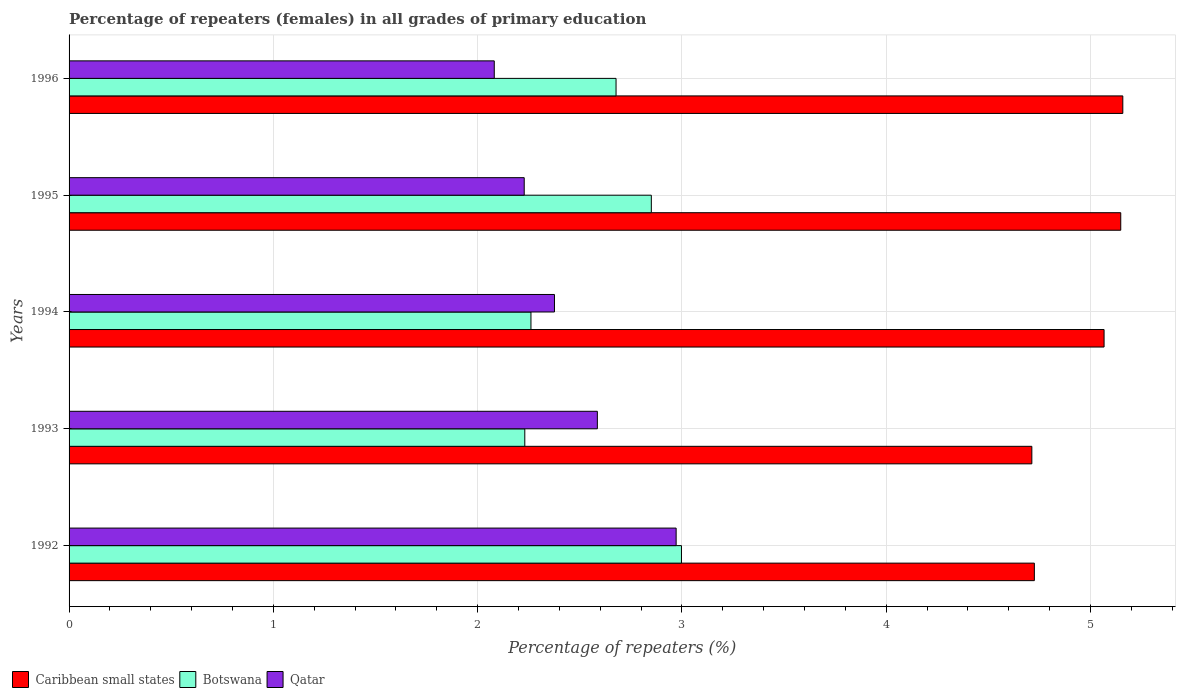How many different coloured bars are there?
Provide a succinct answer. 3. How many groups of bars are there?
Offer a very short reply. 5. How many bars are there on the 3rd tick from the top?
Make the answer very short. 3. How many bars are there on the 2nd tick from the bottom?
Ensure brevity in your answer.  3. What is the percentage of repeaters (females) in Qatar in 1996?
Make the answer very short. 2.08. Across all years, what is the maximum percentage of repeaters (females) in Botswana?
Make the answer very short. 3. Across all years, what is the minimum percentage of repeaters (females) in Caribbean small states?
Make the answer very short. 4.71. In which year was the percentage of repeaters (females) in Botswana minimum?
Ensure brevity in your answer.  1993. What is the total percentage of repeaters (females) in Qatar in the graph?
Make the answer very short. 12.24. What is the difference between the percentage of repeaters (females) in Caribbean small states in 1992 and that in 1995?
Keep it short and to the point. -0.42. What is the difference between the percentage of repeaters (females) in Qatar in 1992 and the percentage of repeaters (females) in Botswana in 1996?
Make the answer very short. 0.29. What is the average percentage of repeaters (females) in Qatar per year?
Provide a short and direct response. 2.45. In the year 1995, what is the difference between the percentage of repeaters (females) in Qatar and percentage of repeaters (females) in Caribbean small states?
Offer a very short reply. -2.92. In how many years, is the percentage of repeaters (females) in Qatar greater than 0.4 %?
Ensure brevity in your answer.  5. What is the ratio of the percentage of repeaters (females) in Caribbean small states in 1994 to that in 1996?
Make the answer very short. 0.98. Is the percentage of repeaters (females) in Qatar in 1992 less than that in 1994?
Offer a very short reply. No. What is the difference between the highest and the second highest percentage of repeaters (females) in Caribbean small states?
Offer a terse response. 0.01. What is the difference between the highest and the lowest percentage of repeaters (females) in Caribbean small states?
Give a very brief answer. 0.45. In how many years, is the percentage of repeaters (females) in Qatar greater than the average percentage of repeaters (females) in Qatar taken over all years?
Your response must be concise. 2. What does the 3rd bar from the top in 1995 represents?
Provide a short and direct response. Caribbean small states. What does the 3rd bar from the bottom in 1992 represents?
Your answer should be compact. Qatar. How many bars are there?
Keep it short and to the point. 15. Are all the bars in the graph horizontal?
Provide a short and direct response. Yes. Does the graph contain any zero values?
Ensure brevity in your answer.  No. Does the graph contain grids?
Keep it short and to the point. Yes. How many legend labels are there?
Give a very brief answer. 3. What is the title of the graph?
Provide a short and direct response. Percentage of repeaters (females) in all grades of primary education. What is the label or title of the X-axis?
Your answer should be very brief. Percentage of repeaters (%). What is the label or title of the Y-axis?
Offer a terse response. Years. What is the Percentage of repeaters (%) in Caribbean small states in 1992?
Your answer should be compact. 4.73. What is the Percentage of repeaters (%) in Botswana in 1992?
Give a very brief answer. 3. What is the Percentage of repeaters (%) of Qatar in 1992?
Give a very brief answer. 2.97. What is the Percentage of repeaters (%) in Caribbean small states in 1993?
Your response must be concise. 4.71. What is the Percentage of repeaters (%) in Botswana in 1993?
Your answer should be compact. 2.23. What is the Percentage of repeaters (%) in Qatar in 1993?
Make the answer very short. 2.59. What is the Percentage of repeaters (%) of Caribbean small states in 1994?
Offer a terse response. 5.07. What is the Percentage of repeaters (%) of Botswana in 1994?
Keep it short and to the point. 2.26. What is the Percentage of repeaters (%) in Qatar in 1994?
Ensure brevity in your answer.  2.38. What is the Percentage of repeaters (%) of Caribbean small states in 1995?
Your answer should be very brief. 5.15. What is the Percentage of repeaters (%) in Botswana in 1995?
Give a very brief answer. 2.85. What is the Percentage of repeaters (%) in Qatar in 1995?
Your answer should be compact. 2.23. What is the Percentage of repeaters (%) in Caribbean small states in 1996?
Keep it short and to the point. 5.16. What is the Percentage of repeaters (%) of Botswana in 1996?
Offer a terse response. 2.68. What is the Percentage of repeaters (%) of Qatar in 1996?
Make the answer very short. 2.08. Across all years, what is the maximum Percentage of repeaters (%) of Caribbean small states?
Offer a terse response. 5.16. Across all years, what is the maximum Percentage of repeaters (%) of Botswana?
Ensure brevity in your answer.  3. Across all years, what is the maximum Percentage of repeaters (%) in Qatar?
Ensure brevity in your answer.  2.97. Across all years, what is the minimum Percentage of repeaters (%) of Caribbean small states?
Make the answer very short. 4.71. Across all years, what is the minimum Percentage of repeaters (%) of Botswana?
Keep it short and to the point. 2.23. Across all years, what is the minimum Percentage of repeaters (%) of Qatar?
Make the answer very short. 2.08. What is the total Percentage of repeaters (%) in Caribbean small states in the graph?
Your response must be concise. 24.81. What is the total Percentage of repeaters (%) of Botswana in the graph?
Ensure brevity in your answer.  13.02. What is the total Percentage of repeaters (%) of Qatar in the graph?
Make the answer very short. 12.24. What is the difference between the Percentage of repeaters (%) in Caribbean small states in 1992 and that in 1993?
Offer a very short reply. 0.01. What is the difference between the Percentage of repeaters (%) in Botswana in 1992 and that in 1993?
Provide a succinct answer. 0.77. What is the difference between the Percentage of repeaters (%) of Qatar in 1992 and that in 1993?
Your answer should be compact. 0.39. What is the difference between the Percentage of repeaters (%) in Caribbean small states in 1992 and that in 1994?
Your answer should be compact. -0.34. What is the difference between the Percentage of repeaters (%) in Botswana in 1992 and that in 1994?
Your response must be concise. 0.74. What is the difference between the Percentage of repeaters (%) in Qatar in 1992 and that in 1994?
Your answer should be very brief. 0.6. What is the difference between the Percentage of repeaters (%) of Caribbean small states in 1992 and that in 1995?
Your response must be concise. -0.42. What is the difference between the Percentage of repeaters (%) in Botswana in 1992 and that in 1995?
Ensure brevity in your answer.  0.15. What is the difference between the Percentage of repeaters (%) of Qatar in 1992 and that in 1995?
Make the answer very short. 0.74. What is the difference between the Percentage of repeaters (%) of Caribbean small states in 1992 and that in 1996?
Offer a very short reply. -0.43. What is the difference between the Percentage of repeaters (%) of Botswana in 1992 and that in 1996?
Your answer should be compact. 0.32. What is the difference between the Percentage of repeaters (%) in Qatar in 1992 and that in 1996?
Make the answer very short. 0.89. What is the difference between the Percentage of repeaters (%) of Caribbean small states in 1993 and that in 1994?
Ensure brevity in your answer.  -0.35. What is the difference between the Percentage of repeaters (%) of Botswana in 1993 and that in 1994?
Provide a succinct answer. -0.03. What is the difference between the Percentage of repeaters (%) of Qatar in 1993 and that in 1994?
Make the answer very short. 0.21. What is the difference between the Percentage of repeaters (%) of Caribbean small states in 1993 and that in 1995?
Give a very brief answer. -0.44. What is the difference between the Percentage of repeaters (%) in Botswana in 1993 and that in 1995?
Ensure brevity in your answer.  -0.62. What is the difference between the Percentage of repeaters (%) in Qatar in 1993 and that in 1995?
Give a very brief answer. 0.36. What is the difference between the Percentage of repeaters (%) in Caribbean small states in 1993 and that in 1996?
Give a very brief answer. -0.45. What is the difference between the Percentage of repeaters (%) of Botswana in 1993 and that in 1996?
Offer a very short reply. -0.45. What is the difference between the Percentage of repeaters (%) of Qatar in 1993 and that in 1996?
Keep it short and to the point. 0.5. What is the difference between the Percentage of repeaters (%) of Caribbean small states in 1994 and that in 1995?
Offer a terse response. -0.08. What is the difference between the Percentage of repeaters (%) in Botswana in 1994 and that in 1995?
Offer a terse response. -0.59. What is the difference between the Percentage of repeaters (%) of Qatar in 1994 and that in 1995?
Offer a terse response. 0.15. What is the difference between the Percentage of repeaters (%) of Caribbean small states in 1994 and that in 1996?
Give a very brief answer. -0.09. What is the difference between the Percentage of repeaters (%) in Botswana in 1994 and that in 1996?
Your answer should be compact. -0.42. What is the difference between the Percentage of repeaters (%) in Qatar in 1994 and that in 1996?
Keep it short and to the point. 0.29. What is the difference between the Percentage of repeaters (%) in Caribbean small states in 1995 and that in 1996?
Offer a terse response. -0.01. What is the difference between the Percentage of repeaters (%) in Botswana in 1995 and that in 1996?
Offer a terse response. 0.17. What is the difference between the Percentage of repeaters (%) in Qatar in 1995 and that in 1996?
Your response must be concise. 0.15. What is the difference between the Percentage of repeaters (%) in Caribbean small states in 1992 and the Percentage of repeaters (%) in Botswana in 1993?
Offer a terse response. 2.49. What is the difference between the Percentage of repeaters (%) of Caribbean small states in 1992 and the Percentage of repeaters (%) of Qatar in 1993?
Give a very brief answer. 2.14. What is the difference between the Percentage of repeaters (%) in Botswana in 1992 and the Percentage of repeaters (%) in Qatar in 1993?
Keep it short and to the point. 0.41. What is the difference between the Percentage of repeaters (%) of Caribbean small states in 1992 and the Percentage of repeaters (%) of Botswana in 1994?
Offer a very short reply. 2.46. What is the difference between the Percentage of repeaters (%) of Caribbean small states in 1992 and the Percentage of repeaters (%) of Qatar in 1994?
Make the answer very short. 2.35. What is the difference between the Percentage of repeaters (%) of Botswana in 1992 and the Percentage of repeaters (%) of Qatar in 1994?
Your answer should be very brief. 0.62. What is the difference between the Percentage of repeaters (%) of Caribbean small states in 1992 and the Percentage of repeaters (%) of Botswana in 1995?
Your response must be concise. 1.88. What is the difference between the Percentage of repeaters (%) in Caribbean small states in 1992 and the Percentage of repeaters (%) in Qatar in 1995?
Keep it short and to the point. 2.5. What is the difference between the Percentage of repeaters (%) in Botswana in 1992 and the Percentage of repeaters (%) in Qatar in 1995?
Make the answer very short. 0.77. What is the difference between the Percentage of repeaters (%) of Caribbean small states in 1992 and the Percentage of repeaters (%) of Botswana in 1996?
Provide a short and direct response. 2.05. What is the difference between the Percentage of repeaters (%) of Caribbean small states in 1992 and the Percentage of repeaters (%) of Qatar in 1996?
Ensure brevity in your answer.  2.64. What is the difference between the Percentage of repeaters (%) in Botswana in 1992 and the Percentage of repeaters (%) in Qatar in 1996?
Give a very brief answer. 0.92. What is the difference between the Percentage of repeaters (%) of Caribbean small states in 1993 and the Percentage of repeaters (%) of Botswana in 1994?
Provide a short and direct response. 2.45. What is the difference between the Percentage of repeaters (%) in Caribbean small states in 1993 and the Percentage of repeaters (%) in Qatar in 1994?
Your answer should be very brief. 2.34. What is the difference between the Percentage of repeaters (%) in Botswana in 1993 and the Percentage of repeaters (%) in Qatar in 1994?
Offer a terse response. -0.15. What is the difference between the Percentage of repeaters (%) of Caribbean small states in 1993 and the Percentage of repeaters (%) of Botswana in 1995?
Offer a terse response. 1.86. What is the difference between the Percentage of repeaters (%) of Caribbean small states in 1993 and the Percentage of repeaters (%) of Qatar in 1995?
Keep it short and to the point. 2.49. What is the difference between the Percentage of repeaters (%) in Botswana in 1993 and the Percentage of repeaters (%) in Qatar in 1995?
Keep it short and to the point. 0. What is the difference between the Percentage of repeaters (%) of Caribbean small states in 1993 and the Percentage of repeaters (%) of Botswana in 1996?
Your response must be concise. 2.04. What is the difference between the Percentage of repeaters (%) in Caribbean small states in 1993 and the Percentage of repeaters (%) in Qatar in 1996?
Ensure brevity in your answer.  2.63. What is the difference between the Percentage of repeaters (%) of Botswana in 1993 and the Percentage of repeaters (%) of Qatar in 1996?
Your answer should be compact. 0.15. What is the difference between the Percentage of repeaters (%) of Caribbean small states in 1994 and the Percentage of repeaters (%) of Botswana in 1995?
Your response must be concise. 2.22. What is the difference between the Percentage of repeaters (%) of Caribbean small states in 1994 and the Percentage of repeaters (%) of Qatar in 1995?
Offer a very short reply. 2.84. What is the difference between the Percentage of repeaters (%) of Botswana in 1994 and the Percentage of repeaters (%) of Qatar in 1995?
Provide a succinct answer. 0.03. What is the difference between the Percentage of repeaters (%) of Caribbean small states in 1994 and the Percentage of repeaters (%) of Botswana in 1996?
Make the answer very short. 2.39. What is the difference between the Percentage of repeaters (%) of Caribbean small states in 1994 and the Percentage of repeaters (%) of Qatar in 1996?
Offer a very short reply. 2.99. What is the difference between the Percentage of repeaters (%) of Botswana in 1994 and the Percentage of repeaters (%) of Qatar in 1996?
Provide a short and direct response. 0.18. What is the difference between the Percentage of repeaters (%) in Caribbean small states in 1995 and the Percentage of repeaters (%) in Botswana in 1996?
Keep it short and to the point. 2.47. What is the difference between the Percentage of repeaters (%) in Caribbean small states in 1995 and the Percentage of repeaters (%) in Qatar in 1996?
Keep it short and to the point. 3.07. What is the difference between the Percentage of repeaters (%) of Botswana in 1995 and the Percentage of repeaters (%) of Qatar in 1996?
Provide a short and direct response. 0.77. What is the average Percentage of repeaters (%) of Caribbean small states per year?
Provide a succinct answer. 4.96. What is the average Percentage of repeaters (%) in Botswana per year?
Give a very brief answer. 2.6. What is the average Percentage of repeaters (%) in Qatar per year?
Offer a very short reply. 2.45. In the year 1992, what is the difference between the Percentage of repeaters (%) in Caribbean small states and Percentage of repeaters (%) in Botswana?
Your answer should be very brief. 1.73. In the year 1992, what is the difference between the Percentage of repeaters (%) of Caribbean small states and Percentage of repeaters (%) of Qatar?
Your answer should be very brief. 1.75. In the year 1992, what is the difference between the Percentage of repeaters (%) of Botswana and Percentage of repeaters (%) of Qatar?
Your answer should be very brief. 0.03. In the year 1993, what is the difference between the Percentage of repeaters (%) in Caribbean small states and Percentage of repeaters (%) in Botswana?
Make the answer very short. 2.48. In the year 1993, what is the difference between the Percentage of repeaters (%) in Caribbean small states and Percentage of repeaters (%) in Qatar?
Keep it short and to the point. 2.13. In the year 1993, what is the difference between the Percentage of repeaters (%) in Botswana and Percentage of repeaters (%) in Qatar?
Make the answer very short. -0.36. In the year 1994, what is the difference between the Percentage of repeaters (%) in Caribbean small states and Percentage of repeaters (%) in Botswana?
Ensure brevity in your answer.  2.81. In the year 1994, what is the difference between the Percentage of repeaters (%) in Caribbean small states and Percentage of repeaters (%) in Qatar?
Offer a very short reply. 2.69. In the year 1994, what is the difference between the Percentage of repeaters (%) of Botswana and Percentage of repeaters (%) of Qatar?
Provide a short and direct response. -0.12. In the year 1995, what is the difference between the Percentage of repeaters (%) of Caribbean small states and Percentage of repeaters (%) of Botswana?
Your response must be concise. 2.3. In the year 1995, what is the difference between the Percentage of repeaters (%) in Caribbean small states and Percentage of repeaters (%) in Qatar?
Keep it short and to the point. 2.92. In the year 1995, what is the difference between the Percentage of repeaters (%) of Botswana and Percentage of repeaters (%) of Qatar?
Make the answer very short. 0.62. In the year 1996, what is the difference between the Percentage of repeaters (%) of Caribbean small states and Percentage of repeaters (%) of Botswana?
Your answer should be compact. 2.48. In the year 1996, what is the difference between the Percentage of repeaters (%) in Caribbean small states and Percentage of repeaters (%) in Qatar?
Your answer should be very brief. 3.08. In the year 1996, what is the difference between the Percentage of repeaters (%) of Botswana and Percentage of repeaters (%) of Qatar?
Keep it short and to the point. 0.6. What is the ratio of the Percentage of repeaters (%) in Caribbean small states in 1992 to that in 1993?
Give a very brief answer. 1. What is the ratio of the Percentage of repeaters (%) of Botswana in 1992 to that in 1993?
Provide a short and direct response. 1.34. What is the ratio of the Percentage of repeaters (%) of Qatar in 1992 to that in 1993?
Your answer should be very brief. 1.15. What is the ratio of the Percentage of repeaters (%) of Caribbean small states in 1992 to that in 1994?
Give a very brief answer. 0.93. What is the ratio of the Percentage of repeaters (%) in Botswana in 1992 to that in 1994?
Provide a succinct answer. 1.33. What is the ratio of the Percentage of repeaters (%) in Qatar in 1992 to that in 1994?
Provide a short and direct response. 1.25. What is the ratio of the Percentage of repeaters (%) in Caribbean small states in 1992 to that in 1995?
Offer a terse response. 0.92. What is the ratio of the Percentage of repeaters (%) of Botswana in 1992 to that in 1995?
Keep it short and to the point. 1.05. What is the ratio of the Percentage of repeaters (%) of Qatar in 1992 to that in 1995?
Make the answer very short. 1.33. What is the ratio of the Percentage of repeaters (%) of Caribbean small states in 1992 to that in 1996?
Give a very brief answer. 0.92. What is the ratio of the Percentage of repeaters (%) in Botswana in 1992 to that in 1996?
Offer a very short reply. 1.12. What is the ratio of the Percentage of repeaters (%) in Qatar in 1992 to that in 1996?
Offer a very short reply. 1.43. What is the ratio of the Percentage of repeaters (%) of Caribbean small states in 1993 to that in 1994?
Provide a succinct answer. 0.93. What is the ratio of the Percentage of repeaters (%) in Botswana in 1993 to that in 1994?
Ensure brevity in your answer.  0.99. What is the ratio of the Percentage of repeaters (%) in Qatar in 1993 to that in 1994?
Provide a short and direct response. 1.09. What is the ratio of the Percentage of repeaters (%) in Caribbean small states in 1993 to that in 1995?
Provide a short and direct response. 0.92. What is the ratio of the Percentage of repeaters (%) in Botswana in 1993 to that in 1995?
Your response must be concise. 0.78. What is the ratio of the Percentage of repeaters (%) of Qatar in 1993 to that in 1995?
Your answer should be very brief. 1.16. What is the ratio of the Percentage of repeaters (%) of Caribbean small states in 1993 to that in 1996?
Offer a very short reply. 0.91. What is the ratio of the Percentage of repeaters (%) of Botswana in 1993 to that in 1996?
Your answer should be very brief. 0.83. What is the ratio of the Percentage of repeaters (%) of Qatar in 1993 to that in 1996?
Offer a very short reply. 1.24. What is the ratio of the Percentage of repeaters (%) in Caribbean small states in 1994 to that in 1995?
Offer a very short reply. 0.98. What is the ratio of the Percentage of repeaters (%) of Botswana in 1994 to that in 1995?
Ensure brevity in your answer.  0.79. What is the ratio of the Percentage of repeaters (%) of Qatar in 1994 to that in 1995?
Make the answer very short. 1.07. What is the ratio of the Percentage of repeaters (%) in Caribbean small states in 1994 to that in 1996?
Your response must be concise. 0.98. What is the ratio of the Percentage of repeaters (%) of Botswana in 1994 to that in 1996?
Ensure brevity in your answer.  0.84. What is the ratio of the Percentage of repeaters (%) of Qatar in 1994 to that in 1996?
Ensure brevity in your answer.  1.14. What is the ratio of the Percentage of repeaters (%) of Botswana in 1995 to that in 1996?
Offer a terse response. 1.06. What is the ratio of the Percentage of repeaters (%) in Qatar in 1995 to that in 1996?
Ensure brevity in your answer.  1.07. What is the difference between the highest and the second highest Percentage of repeaters (%) in Botswana?
Offer a terse response. 0.15. What is the difference between the highest and the second highest Percentage of repeaters (%) in Qatar?
Give a very brief answer. 0.39. What is the difference between the highest and the lowest Percentage of repeaters (%) in Caribbean small states?
Provide a short and direct response. 0.45. What is the difference between the highest and the lowest Percentage of repeaters (%) in Botswana?
Your answer should be very brief. 0.77. What is the difference between the highest and the lowest Percentage of repeaters (%) of Qatar?
Your answer should be compact. 0.89. 